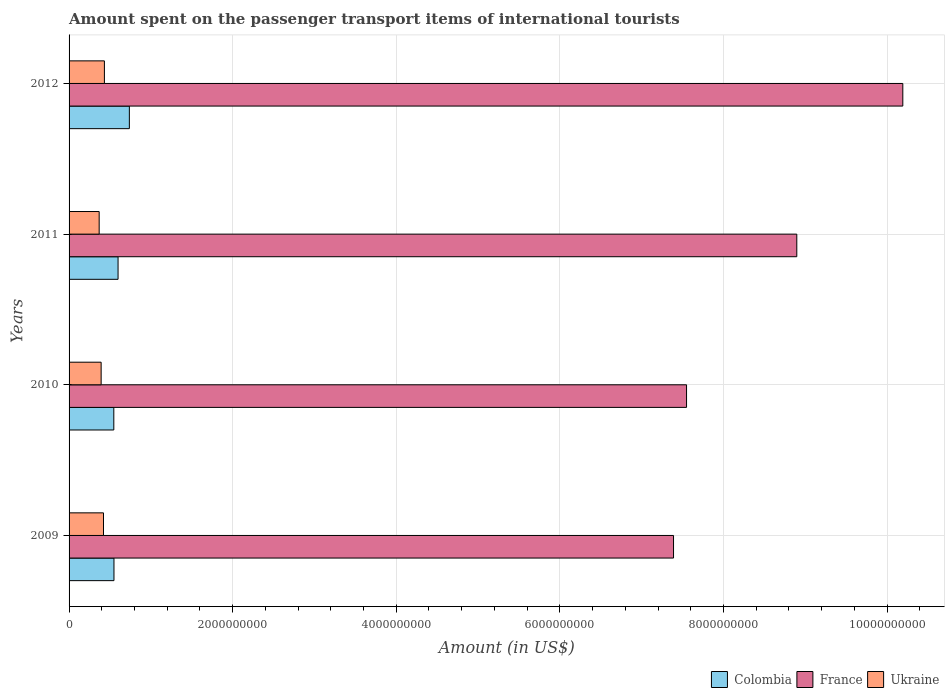How many different coloured bars are there?
Your answer should be very brief. 3. How many bars are there on the 2nd tick from the top?
Your answer should be very brief. 3. What is the label of the 3rd group of bars from the top?
Give a very brief answer. 2010. What is the amount spent on the passenger transport items of international tourists in France in 2010?
Your answer should be very brief. 7.55e+09. Across all years, what is the maximum amount spent on the passenger transport items of international tourists in Colombia?
Offer a very short reply. 7.37e+08. Across all years, what is the minimum amount spent on the passenger transport items of international tourists in France?
Your response must be concise. 7.39e+09. What is the total amount spent on the passenger transport items of international tourists in France in the graph?
Give a very brief answer. 3.40e+1. What is the difference between the amount spent on the passenger transport items of international tourists in France in 2010 and that in 2011?
Give a very brief answer. -1.35e+09. What is the difference between the amount spent on the passenger transport items of international tourists in Ukraine in 2010 and the amount spent on the passenger transport items of international tourists in Colombia in 2009?
Ensure brevity in your answer.  -1.57e+08. What is the average amount spent on the passenger transport items of international tourists in Colombia per year?
Your answer should be very brief. 6.08e+08. In the year 2012, what is the difference between the amount spent on the passenger transport items of international tourists in Colombia and amount spent on the passenger transport items of international tourists in France?
Your response must be concise. -9.46e+09. In how many years, is the amount spent on the passenger transport items of international tourists in Colombia greater than 4000000000 US$?
Provide a short and direct response. 0. What is the ratio of the amount spent on the passenger transport items of international tourists in Colombia in 2010 to that in 2012?
Ensure brevity in your answer.  0.74. Is the difference between the amount spent on the passenger transport items of international tourists in Colombia in 2011 and 2012 greater than the difference between the amount spent on the passenger transport items of international tourists in France in 2011 and 2012?
Ensure brevity in your answer.  Yes. What is the difference between the highest and the second highest amount spent on the passenger transport items of international tourists in Ukraine?
Ensure brevity in your answer.  1.10e+07. What is the difference between the highest and the lowest amount spent on the passenger transport items of international tourists in Colombia?
Ensure brevity in your answer.  1.90e+08. In how many years, is the amount spent on the passenger transport items of international tourists in France greater than the average amount spent on the passenger transport items of international tourists in France taken over all years?
Your answer should be very brief. 2. What does the 3rd bar from the top in 2011 represents?
Keep it short and to the point. Colombia. What does the 3rd bar from the bottom in 2011 represents?
Your answer should be very brief. Ukraine. How many years are there in the graph?
Your response must be concise. 4. What is the difference between two consecutive major ticks on the X-axis?
Provide a succinct answer. 2.00e+09. Are the values on the major ticks of X-axis written in scientific E-notation?
Provide a succinct answer. No. Does the graph contain any zero values?
Provide a succinct answer. No. Does the graph contain grids?
Give a very brief answer. Yes. How are the legend labels stacked?
Offer a terse response. Horizontal. What is the title of the graph?
Provide a short and direct response. Amount spent on the passenger transport items of international tourists. What is the label or title of the X-axis?
Your answer should be very brief. Amount (in US$). What is the Amount (in US$) of Colombia in 2009?
Give a very brief answer. 5.49e+08. What is the Amount (in US$) in France in 2009?
Provide a short and direct response. 7.39e+09. What is the Amount (in US$) in Ukraine in 2009?
Your response must be concise. 4.21e+08. What is the Amount (in US$) of Colombia in 2010?
Your answer should be compact. 5.47e+08. What is the Amount (in US$) of France in 2010?
Keep it short and to the point. 7.55e+09. What is the Amount (in US$) in Ukraine in 2010?
Provide a short and direct response. 3.92e+08. What is the Amount (in US$) of Colombia in 2011?
Provide a short and direct response. 5.99e+08. What is the Amount (in US$) in France in 2011?
Keep it short and to the point. 8.90e+09. What is the Amount (in US$) of Ukraine in 2011?
Provide a succinct answer. 3.68e+08. What is the Amount (in US$) in Colombia in 2012?
Provide a short and direct response. 7.37e+08. What is the Amount (in US$) of France in 2012?
Provide a succinct answer. 1.02e+1. What is the Amount (in US$) in Ukraine in 2012?
Offer a terse response. 4.32e+08. Across all years, what is the maximum Amount (in US$) in Colombia?
Make the answer very short. 7.37e+08. Across all years, what is the maximum Amount (in US$) of France?
Give a very brief answer. 1.02e+1. Across all years, what is the maximum Amount (in US$) in Ukraine?
Offer a terse response. 4.32e+08. Across all years, what is the minimum Amount (in US$) of Colombia?
Your answer should be very brief. 5.47e+08. Across all years, what is the minimum Amount (in US$) of France?
Your answer should be very brief. 7.39e+09. Across all years, what is the minimum Amount (in US$) in Ukraine?
Ensure brevity in your answer.  3.68e+08. What is the total Amount (in US$) of Colombia in the graph?
Keep it short and to the point. 2.43e+09. What is the total Amount (in US$) in France in the graph?
Offer a very short reply. 3.40e+1. What is the total Amount (in US$) of Ukraine in the graph?
Your answer should be very brief. 1.61e+09. What is the difference between the Amount (in US$) of Colombia in 2009 and that in 2010?
Your response must be concise. 2.00e+06. What is the difference between the Amount (in US$) in France in 2009 and that in 2010?
Provide a short and direct response. -1.59e+08. What is the difference between the Amount (in US$) in Ukraine in 2009 and that in 2010?
Make the answer very short. 2.90e+07. What is the difference between the Amount (in US$) of Colombia in 2009 and that in 2011?
Provide a short and direct response. -5.00e+07. What is the difference between the Amount (in US$) in France in 2009 and that in 2011?
Your answer should be very brief. -1.51e+09. What is the difference between the Amount (in US$) of Ukraine in 2009 and that in 2011?
Offer a terse response. 5.30e+07. What is the difference between the Amount (in US$) of Colombia in 2009 and that in 2012?
Provide a succinct answer. -1.88e+08. What is the difference between the Amount (in US$) in France in 2009 and that in 2012?
Make the answer very short. -2.80e+09. What is the difference between the Amount (in US$) of Ukraine in 2009 and that in 2012?
Provide a short and direct response. -1.10e+07. What is the difference between the Amount (in US$) of Colombia in 2010 and that in 2011?
Provide a short and direct response. -5.20e+07. What is the difference between the Amount (in US$) in France in 2010 and that in 2011?
Offer a terse response. -1.35e+09. What is the difference between the Amount (in US$) of Ukraine in 2010 and that in 2011?
Your response must be concise. 2.40e+07. What is the difference between the Amount (in US$) in Colombia in 2010 and that in 2012?
Make the answer very short. -1.90e+08. What is the difference between the Amount (in US$) of France in 2010 and that in 2012?
Offer a very short reply. -2.64e+09. What is the difference between the Amount (in US$) of Ukraine in 2010 and that in 2012?
Your response must be concise. -4.00e+07. What is the difference between the Amount (in US$) in Colombia in 2011 and that in 2012?
Make the answer very short. -1.38e+08. What is the difference between the Amount (in US$) in France in 2011 and that in 2012?
Provide a succinct answer. -1.30e+09. What is the difference between the Amount (in US$) in Ukraine in 2011 and that in 2012?
Make the answer very short. -6.40e+07. What is the difference between the Amount (in US$) in Colombia in 2009 and the Amount (in US$) in France in 2010?
Offer a very short reply. -7.00e+09. What is the difference between the Amount (in US$) of Colombia in 2009 and the Amount (in US$) of Ukraine in 2010?
Your response must be concise. 1.57e+08. What is the difference between the Amount (in US$) of France in 2009 and the Amount (in US$) of Ukraine in 2010?
Give a very brief answer. 7.00e+09. What is the difference between the Amount (in US$) of Colombia in 2009 and the Amount (in US$) of France in 2011?
Provide a short and direct response. -8.35e+09. What is the difference between the Amount (in US$) in Colombia in 2009 and the Amount (in US$) in Ukraine in 2011?
Provide a succinct answer. 1.81e+08. What is the difference between the Amount (in US$) of France in 2009 and the Amount (in US$) of Ukraine in 2011?
Ensure brevity in your answer.  7.02e+09. What is the difference between the Amount (in US$) in Colombia in 2009 and the Amount (in US$) in France in 2012?
Provide a succinct answer. -9.64e+09. What is the difference between the Amount (in US$) of Colombia in 2009 and the Amount (in US$) of Ukraine in 2012?
Your response must be concise. 1.17e+08. What is the difference between the Amount (in US$) of France in 2009 and the Amount (in US$) of Ukraine in 2012?
Offer a terse response. 6.96e+09. What is the difference between the Amount (in US$) of Colombia in 2010 and the Amount (in US$) of France in 2011?
Your response must be concise. -8.35e+09. What is the difference between the Amount (in US$) of Colombia in 2010 and the Amount (in US$) of Ukraine in 2011?
Provide a short and direct response. 1.79e+08. What is the difference between the Amount (in US$) in France in 2010 and the Amount (in US$) in Ukraine in 2011?
Keep it short and to the point. 7.18e+09. What is the difference between the Amount (in US$) in Colombia in 2010 and the Amount (in US$) in France in 2012?
Your response must be concise. -9.65e+09. What is the difference between the Amount (in US$) in Colombia in 2010 and the Amount (in US$) in Ukraine in 2012?
Make the answer very short. 1.15e+08. What is the difference between the Amount (in US$) in France in 2010 and the Amount (in US$) in Ukraine in 2012?
Provide a succinct answer. 7.12e+09. What is the difference between the Amount (in US$) of Colombia in 2011 and the Amount (in US$) of France in 2012?
Your answer should be compact. -9.59e+09. What is the difference between the Amount (in US$) of Colombia in 2011 and the Amount (in US$) of Ukraine in 2012?
Give a very brief answer. 1.67e+08. What is the difference between the Amount (in US$) of France in 2011 and the Amount (in US$) of Ukraine in 2012?
Provide a short and direct response. 8.46e+09. What is the average Amount (in US$) of Colombia per year?
Your answer should be very brief. 6.08e+08. What is the average Amount (in US$) of France per year?
Give a very brief answer. 8.51e+09. What is the average Amount (in US$) of Ukraine per year?
Your answer should be very brief. 4.03e+08. In the year 2009, what is the difference between the Amount (in US$) in Colombia and Amount (in US$) in France?
Offer a very short reply. -6.84e+09. In the year 2009, what is the difference between the Amount (in US$) of Colombia and Amount (in US$) of Ukraine?
Give a very brief answer. 1.28e+08. In the year 2009, what is the difference between the Amount (in US$) in France and Amount (in US$) in Ukraine?
Give a very brief answer. 6.97e+09. In the year 2010, what is the difference between the Amount (in US$) in Colombia and Amount (in US$) in France?
Provide a short and direct response. -7.00e+09. In the year 2010, what is the difference between the Amount (in US$) in Colombia and Amount (in US$) in Ukraine?
Provide a succinct answer. 1.55e+08. In the year 2010, what is the difference between the Amount (in US$) in France and Amount (in US$) in Ukraine?
Your answer should be very brief. 7.16e+09. In the year 2011, what is the difference between the Amount (in US$) in Colombia and Amount (in US$) in France?
Ensure brevity in your answer.  -8.30e+09. In the year 2011, what is the difference between the Amount (in US$) in Colombia and Amount (in US$) in Ukraine?
Your answer should be very brief. 2.31e+08. In the year 2011, what is the difference between the Amount (in US$) in France and Amount (in US$) in Ukraine?
Your response must be concise. 8.53e+09. In the year 2012, what is the difference between the Amount (in US$) of Colombia and Amount (in US$) of France?
Provide a succinct answer. -9.46e+09. In the year 2012, what is the difference between the Amount (in US$) of Colombia and Amount (in US$) of Ukraine?
Offer a very short reply. 3.05e+08. In the year 2012, what is the difference between the Amount (in US$) in France and Amount (in US$) in Ukraine?
Keep it short and to the point. 9.76e+09. What is the ratio of the Amount (in US$) of Colombia in 2009 to that in 2010?
Keep it short and to the point. 1. What is the ratio of the Amount (in US$) in France in 2009 to that in 2010?
Your response must be concise. 0.98. What is the ratio of the Amount (in US$) of Ukraine in 2009 to that in 2010?
Give a very brief answer. 1.07. What is the ratio of the Amount (in US$) of Colombia in 2009 to that in 2011?
Ensure brevity in your answer.  0.92. What is the ratio of the Amount (in US$) of France in 2009 to that in 2011?
Your answer should be very brief. 0.83. What is the ratio of the Amount (in US$) of Ukraine in 2009 to that in 2011?
Your response must be concise. 1.14. What is the ratio of the Amount (in US$) in Colombia in 2009 to that in 2012?
Make the answer very short. 0.74. What is the ratio of the Amount (in US$) of France in 2009 to that in 2012?
Offer a very short reply. 0.72. What is the ratio of the Amount (in US$) in Ukraine in 2009 to that in 2012?
Keep it short and to the point. 0.97. What is the ratio of the Amount (in US$) in Colombia in 2010 to that in 2011?
Offer a terse response. 0.91. What is the ratio of the Amount (in US$) in France in 2010 to that in 2011?
Ensure brevity in your answer.  0.85. What is the ratio of the Amount (in US$) of Ukraine in 2010 to that in 2011?
Offer a very short reply. 1.07. What is the ratio of the Amount (in US$) of Colombia in 2010 to that in 2012?
Your answer should be compact. 0.74. What is the ratio of the Amount (in US$) of France in 2010 to that in 2012?
Provide a short and direct response. 0.74. What is the ratio of the Amount (in US$) in Ukraine in 2010 to that in 2012?
Give a very brief answer. 0.91. What is the ratio of the Amount (in US$) of Colombia in 2011 to that in 2012?
Your answer should be very brief. 0.81. What is the ratio of the Amount (in US$) in France in 2011 to that in 2012?
Keep it short and to the point. 0.87. What is the ratio of the Amount (in US$) in Ukraine in 2011 to that in 2012?
Offer a terse response. 0.85. What is the difference between the highest and the second highest Amount (in US$) of Colombia?
Give a very brief answer. 1.38e+08. What is the difference between the highest and the second highest Amount (in US$) of France?
Provide a short and direct response. 1.30e+09. What is the difference between the highest and the second highest Amount (in US$) in Ukraine?
Ensure brevity in your answer.  1.10e+07. What is the difference between the highest and the lowest Amount (in US$) of Colombia?
Your answer should be very brief. 1.90e+08. What is the difference between the highest and the lowest Amount (in US$) in France?
Ensure brevity in your answer.  2.80e+09. What is the difference between the highest and the lowest Amount (in US$) of Ukraine?
Make the answer very short. 6.40e+07. 